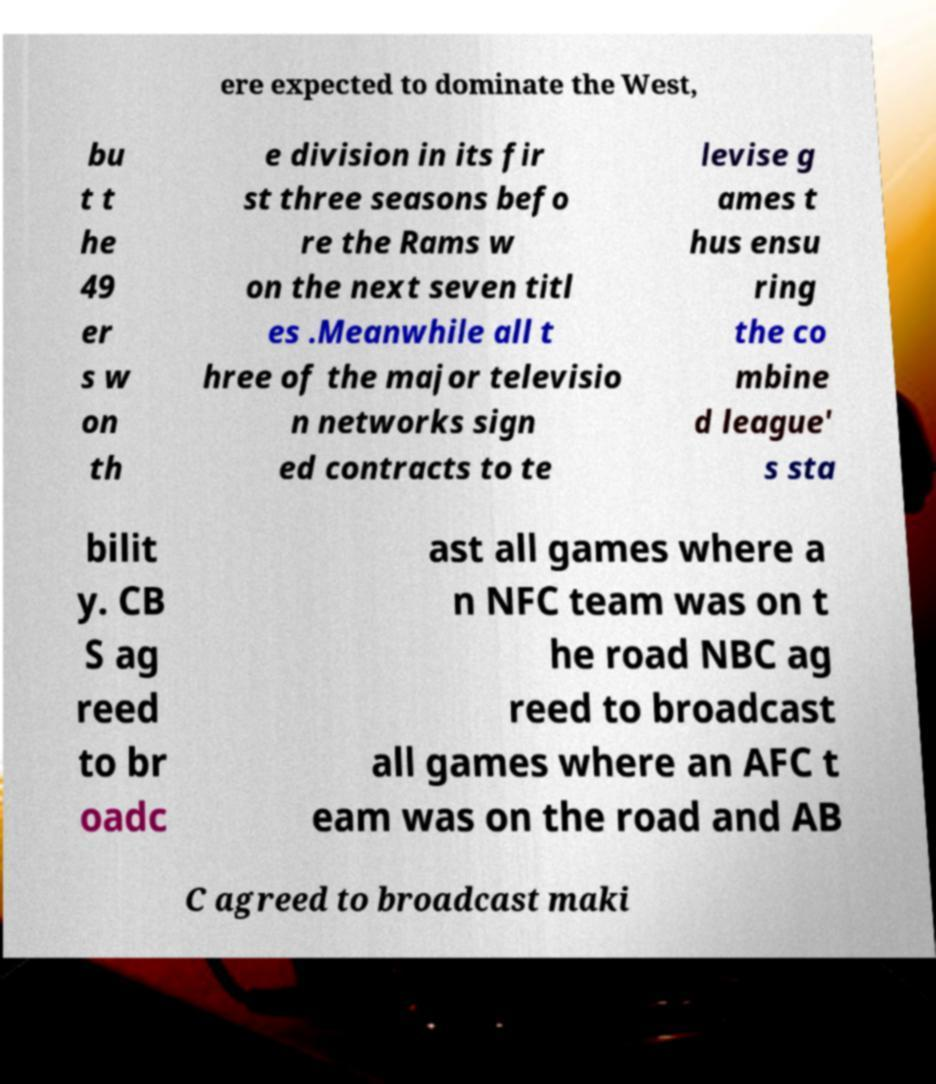Can you accurately transcribe the text from the provided image for me? ere expected to dominate the West, bu t t he 49 er s w on th e division in its fir st three seasons befo re the Rams w on the next seven titl es .Meanwhile all t hree of the major televisio n networks sign ed contracts to te levise g ames t hus ensu ring the co mbine d league' s sta bilit y. CB S ag reed to br oadc ast all games where a n NFC team was on t he road NBC ag reed to broadcast all games where an AFC t eam was on the road and AB C agreed to broadcast maki 